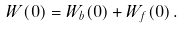<formula> <loc_0><loc_0><loc_500><loc_500>W ( 0 ) = W _ { b } ( 0 ) + W _ { f } ( 0 ) \, .</formula> 